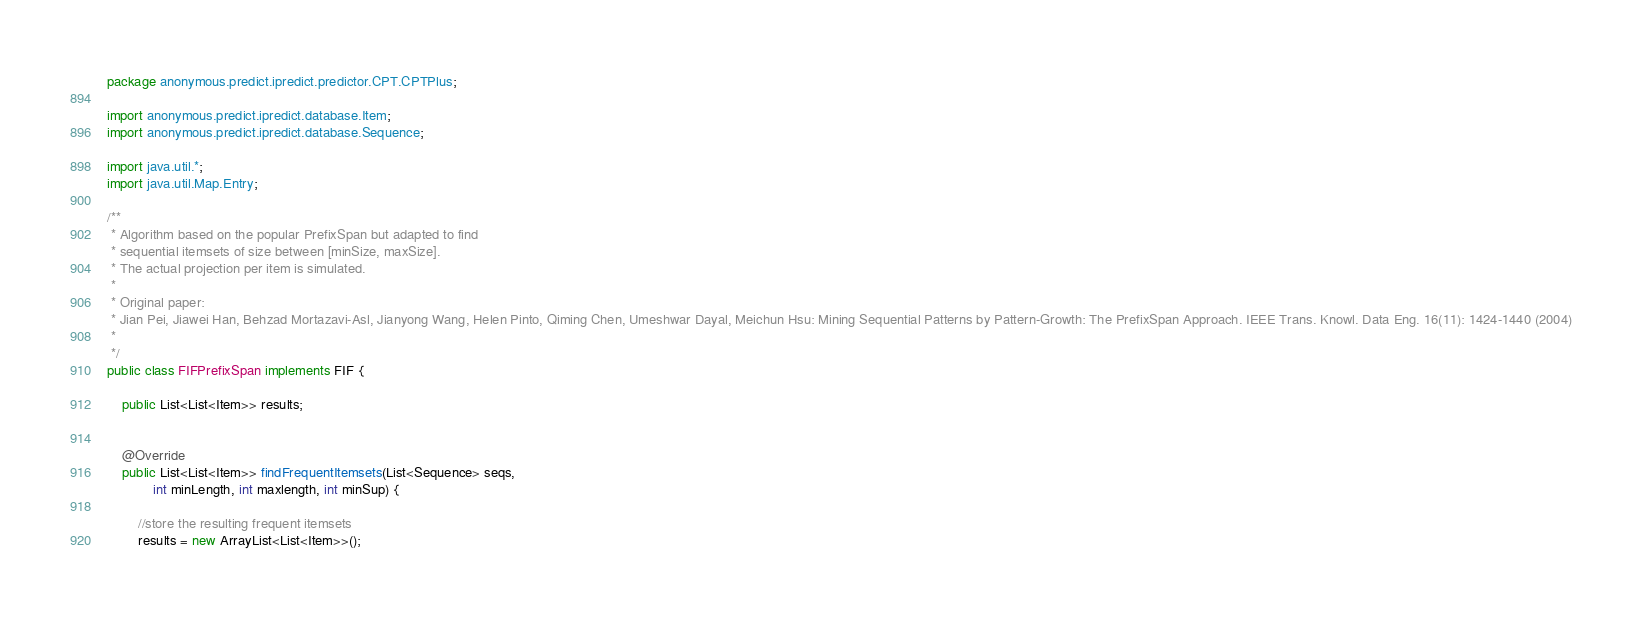Convert code to text. <code><loc_0><loc_0><loc_500><loc_500><_Java_>package anonymous.predict.ipredict.predictor.CPT.CPTPlus;

import anonymous.predict.ipredict.database.Item;
import anonymous.predict.ipredict.database.Sequence;

import java.util.*;
import java.util.Map.Entry;

/**
 * Algorithm based on the popular PrefixSpan but adapted to find
 * sequential itemsets of size between [minSize, maxSize].
 * The actual projection per item is simulated.
 * 
 * Original paper:
 * Jian Pei, Jiawei Han, Behzad Mortazavi-Asl, Jianyong Wang, Helen Pinto, Qiming Chen, Umeshwar Dayal, Meichun Hsu: Mining Sequential Patterns by Pattern-Growth: The PrefixSpan Approach. IEEE Trans. Knowl. Data Eng. 16(11): 1424-1440 (2004)
 *
 */
public class FIFPrefixSpan implements FIF {

	public List<List<Item>> results;
	
	
	@Override
	public List<List<Item>> findFrequentItemsets(List<Sequence> seqs,
			int minLength, int maxlength, int minSup) {
		
		//store the resulting frequent itemsets
		results = new ArrayList<List<Item>>();
		</code> 